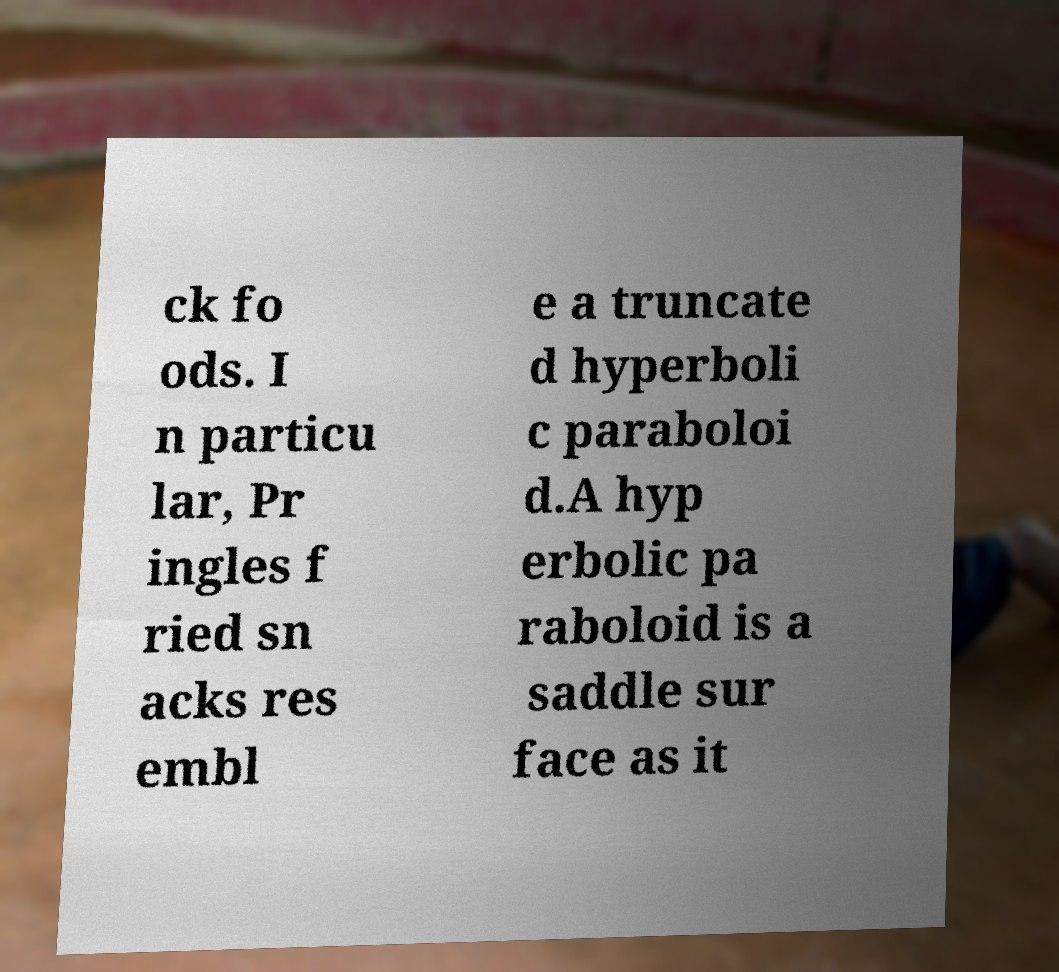Please read and relay the text visible in this image. What does it say? ck fo ods. I n particu lar, Pr ingles f ried sn acks res embl e a truncate d hyperboli c paraboloi d.A hyp erbolic pa raboloid is a saddle sur face as it 